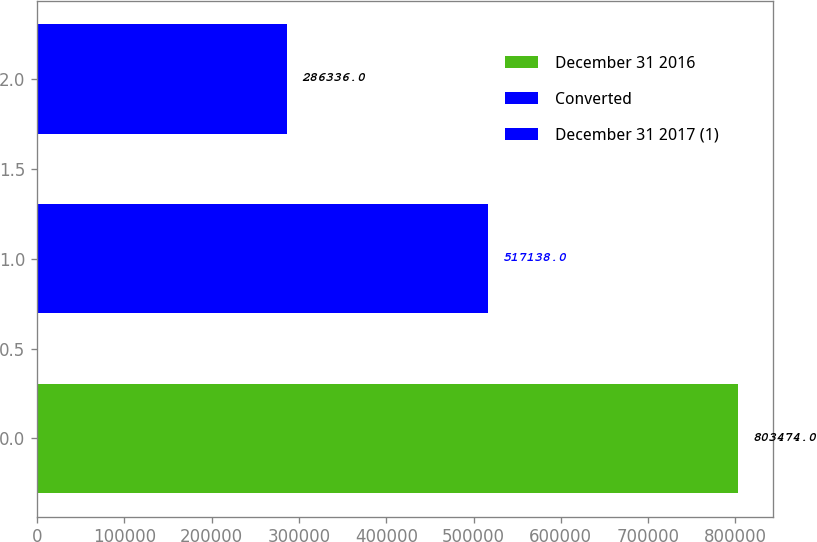Convert chart to OTSL. <chart><loc_0><loc_0><loc_500><loc_500><bar_chart><fcel>December 31 2016<fcel>Converted<fcel>December 31 2017 (1)<nl><fcel>803474<fcel>517138<fcel>286336<nl></chart> 